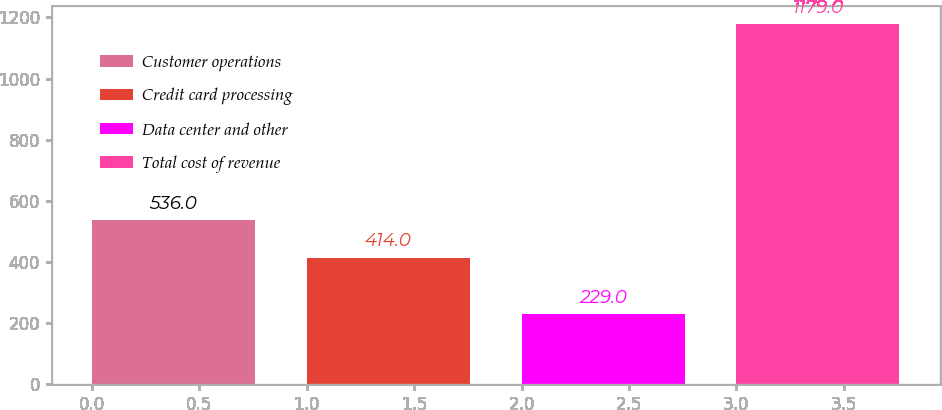Convert chart to OTSL. <chart><loc_0><loc_0><loc_500><loc_500><bar_chart><fcel>Customer operations<fcel>Credit card processing<fcel>Data center and other<fcel>Total cost of revenue<nl><fcel>536<fcel>414<fcel>229<fcel>1179<nl></chart> 